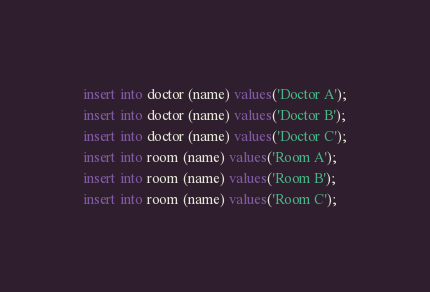Convert code to text. <code><loc_0><loc_0><loc_500><loc_500><_SQL_>insert into doctor (name) values('Doctor A');
insert into doctor (name) values('Doctor B');
insert into doctor (name) values('Doctor C');
insert into room (name) values('Room A');
insert into room (name) values('Room B');
insert into room (name) values('Room C');</code> 